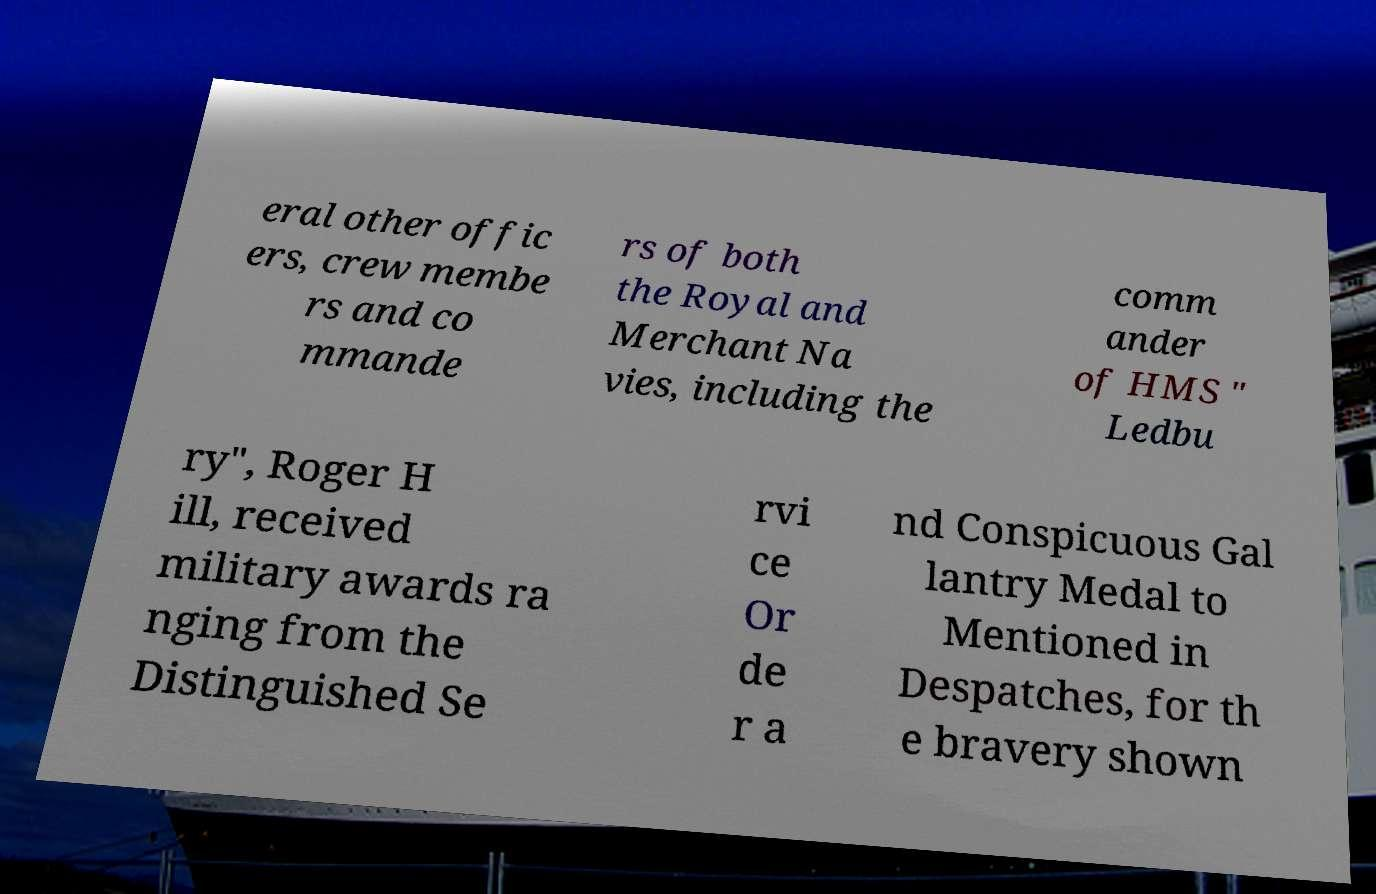I need the written content from this picture converted into text. Can you do that? eral other offic ers, crew membe rs and co mmande rs of both the Royal and Merchant Na vies, including the comm ander of HMS " Ledbu ry", Roger H ill, received military awards ra nging from the Distinguished Se rvi ce Or de r a nd Conspicuous Gal lantry Medal to Mentioned in Despatches, for th e bravery shown 